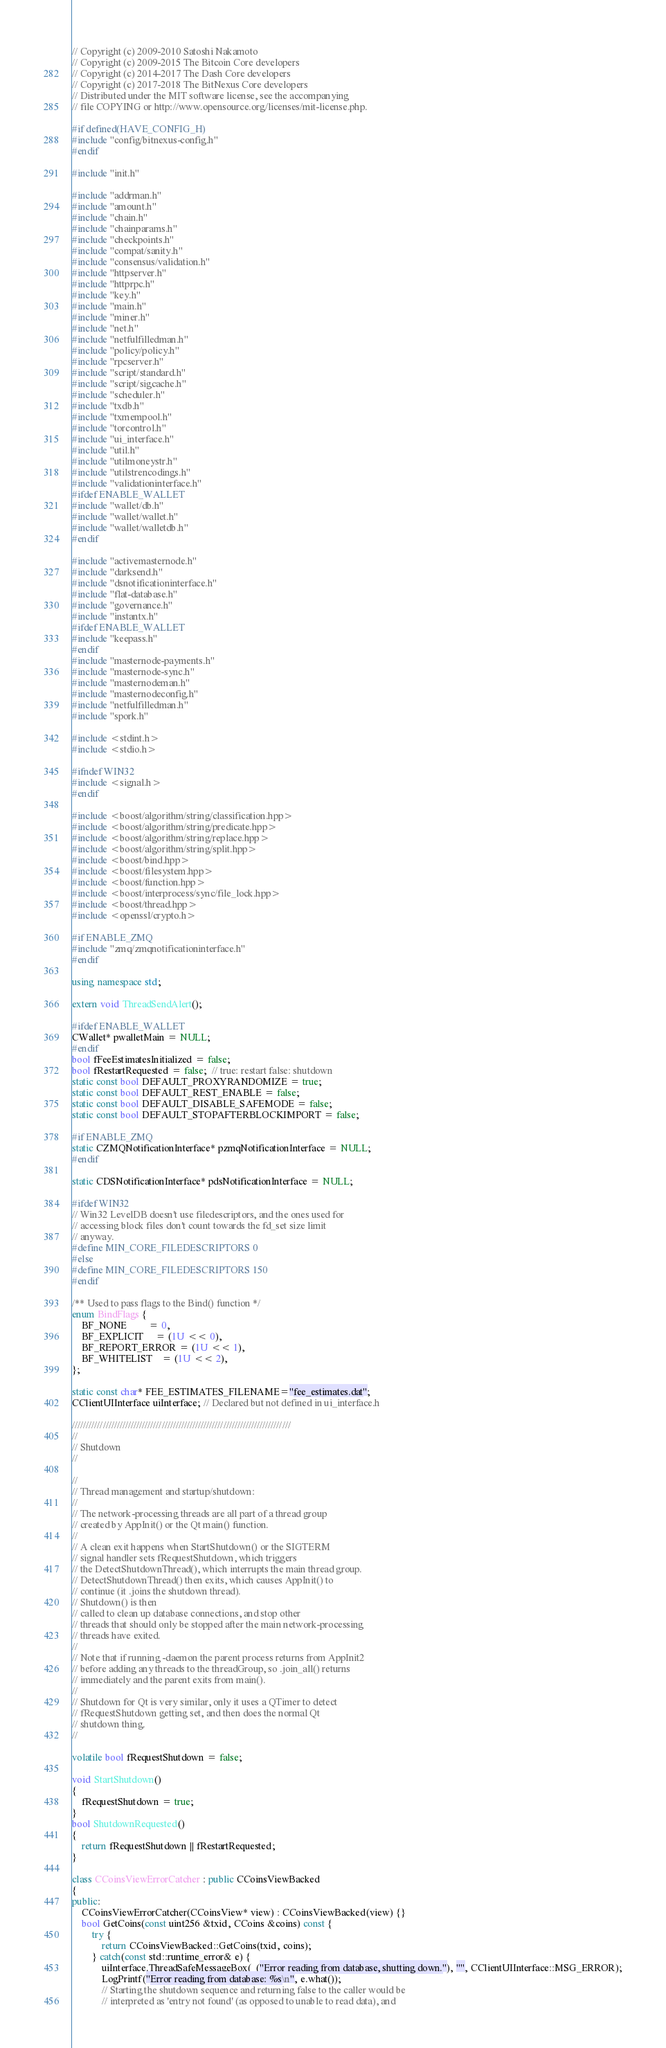Convert code to text. <code><loc_0><loc_0><loc_500><loc_500><_C++_>// Copyright (c) 2009-2010 Satoshi Nakamoto
// Copyright (c) 2009-2015 The Bitcoin Core developers
// Copyright (c) 2014-2017 The Dash Core developers
// Copyright (c) 2017-2018 The BitNexus Core developers
// Distributed under the MIT software license, see the accompanying
// file COPYING or http://www.opensource.org/licenses/mit-license.php.

#if defined(HAVE_CONFIG_H)
#include "config/bitnexus-config.h"
#endif

#include "init.h"

#include "addrman.h"
#include "amount.h"
#include "chain.h"
#include "chainparams.h"
#include "checkpoints.h"
#include "compat/sanity.h"
#include "consensus/validation.h"
#include "httpserver.h"
#include "httprpc.h"
#include "key.h"
#include "main.h"
#include "miner.h"
#include "net.h"
#include "netfulfilledman.h"
#include "policy/policy.h"
#include "rpcserver.h"
#include "script/standard.h"
#include "script/sigcache.h"
#include "scheduler.h"
#include "txdb.h"
#include "txmempool.h"
#include "torcontrol.h"
#include "ui_interface.h"
#include "util.h"
#include "utilmoneystr.h"
#include "utilstrencodings.h"
#include "validationinterface.h"
#ifdef ENABLE_WALLET
#include "wallet/db.h"
#include "wallet/wallet.h"
#include "wallet/walletdb.h"
#endif

#include "activemasternode.h"
#include "darksend.h"
#include "dsnotificationinterface.h"
#include "flat-database.h"
#include "governance.h"
#include "instantx.h"
#ifdef ENABLE_WALLET
#include "keepass.h"
#endif
#include "masternode-payments.h"
#include "masternode-sync.h"
#include "masternodeman.h"
#include "masternodeconfig.h"
#include "netfulfilledman.h"
#include "spork.h"

#include <stdint.h>
#include <stdio.h>

#ifndef WIN32
#include <signal.h>
#endif

#include <boost/algorithm/string/classification.hpp>
#include <boost/algorithm/string/predicate.hpp>
#include <boost/algorithm/string/replace.hpp>
#include <boost/algorithm/string/split.hpp>
#include <boost/bind.hpp>
#include <boost/filesystem.hpp>
#include <boost/function.hpp>
#include <boost/interprocess/sync/file_lock.hpp>
#include <boost/thread.hpp>
#include <openssl/crypto.h>

#if ENABLE_ZMQ
#include "zmq/zmqnotificationinterface.h"
#endif

using namespace std;

extern void ThreadSendAlert();

#ifdef ENABLE_WALLET
CWallet* pwalletMain = NULL;
#endif
bool fFeeEstimatesInitialized = false;
bool fRestartRequested = false;  // true: restart false: shutdown
static const bool DEFAULT_PROXYRANDOMIZE = true;
static const bool DEFAULT_REST_ENABLE = false;
static const bool DEFAULT_DISABLE_SAFEMODE = false;
static const bool DEFAULT_STOPAFTERBLOCKIMPORT = false;

#if ENABLE_ZMQ
static CZMQNotificationInterface* pzmqNotificationInterface = NULL;
#endif

static CDSNotificationInterface* pdsNotificationInterface = NULL;

#ifdef WIN32
// Win32 LevelDB doesn't use filedescriptors, and the ones used for
// accessing block files don't count towards the fd_set size limit
// anyway.
#define MIN_CORE_FILEDESCRIPTORS 0
#else
#define MIN_CORE_FILEDESCRIPTORS 150
#endif

/** Used to pass flags to the Bind() function */
enum BindFlags {
    BF_NONE         = 0,
    BF_EXPLICIT     = (1U << 0),
    BF_REPORT_ERROR = (1U << 1),
    BF_WHITELIST    = (1U << 2),
};

static const char* FEE_ESTIMATES_FILENAME="fee_estimates.dat";
CClientUIInterface uiInterface; // Declared but not defined in ui_interface.h

//////////////////////////////////////////////////////////////////////////////
//
// Shutdown
//

//
// Thread management and startup/shutdown:
//
// The network-processing threads are all part of a thread group
// created by AppInit() or the Qt main() function.
//
// A clean exit happens when StartShutdown() or the SIGTERM
// signal handler sets fRequestShutdown, which triggers
// the DetectShutdownThread(), which interrupts the main thread group.
// DetectShutdownThread() then exits, which causes AppInit() to
// continue (it .joins the shutdown thread).
// Shutdown() is then
// called to clean up database connections, and stop other
// threads that should only be stopped after the main network-processing
// threads have exited.
//
// Note that if running -daemon the parent process returns from AppInit2
// before adding any threads to the threadGroup, so .join_all() returns
// immediately and the parent exits from main().
//
// Shutdown for Qt is very similar, only it uses a QTimer to detect
// fRequestShutdown getting set, and then does the normal Qt
// shutdown thing.
//

volatile bool fRequestShutdown = false;

void StartShutdown()
{
    fRequestShutdown = true;
}
bool ShutdownRequested()
{
    return fRequestShutdown || fRestartRequested;
}

class CCoinsViewErrorCatcher : public CCoinsViewBacked
{
public:
    CCoinsViewErrorCatcher(CCoinsView* view) : CCoinsViewBacked(view) {}
    bool GetCoins(const uint256 &txid, CCoins &coins) const {
        try {
            return CCoinsViewBacked::GetCoins(txid, coins);
        } catch(const std::runtime_error& e) {
            uiInterface.ThreadSafeMessageBox(_("Error reading from database, shutting down."), "", CClientUIInterface::MSG_ERROR);
            LogPrintf("Error reading from database: %s\n", e.what());
            // Starting the shutdown sequence and returning false to the caller would be
            // interpreted as 'entry not found' (as opposed to unable to read data), and</code> 